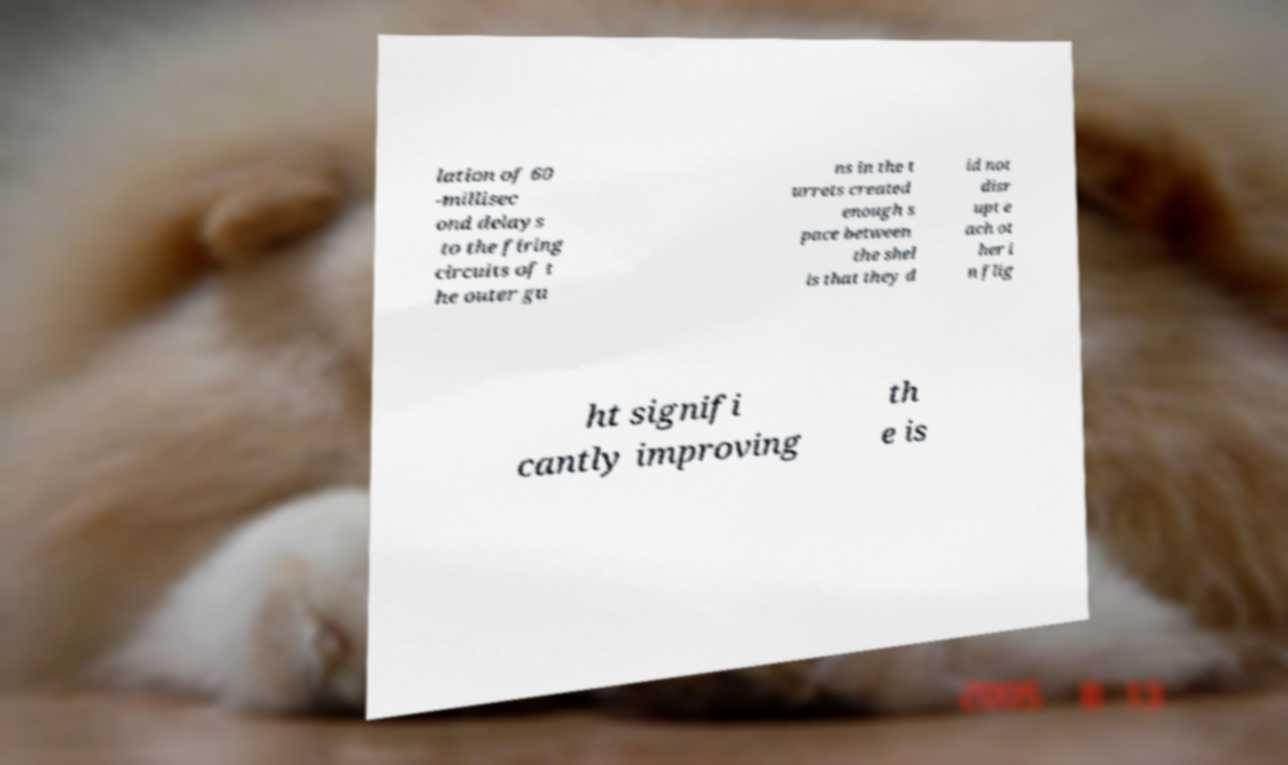Please read and relay the text visible in this image. What does it say? lation of 60 -millisec ond delays to the firing circuits of t he outer gu ns in the t urrets created enough s pace between the shel ls that they d id not disr upt e ach ot her i n flig ht signifi cantly improving th e is 